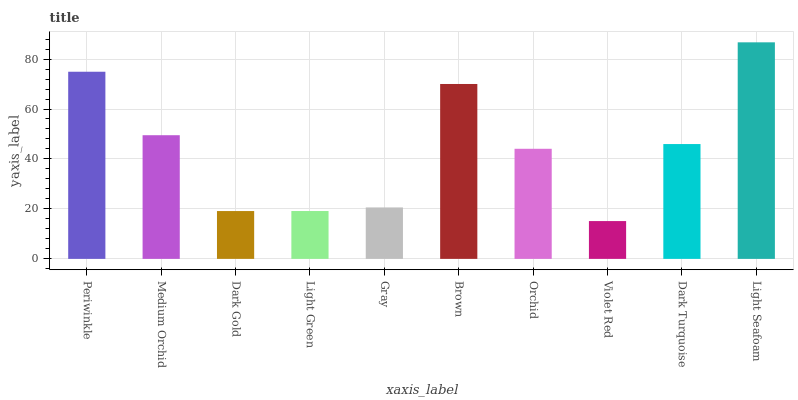Is Violet Red the minimum?
Answer yes or no. Yes. Is Light Seafoam the maximum?
Answer yes or no. Yes. Is Medium Orchid the minimum?
Answer yes or no. No. Is Medium Orchid the maximum?
Answer yes or no. No. Is Periwinkle greater than Medium Orchid?
Answer yes or no. Yes. Is Medium Orchid less than Periwinkle?
Answer yes or no. Yes. Is Medium Orchid greater than Periwinkle?
Answer yes or no. No. Is Periwinkle less than Medium Orchid?
Answer yes or no. No. Is Dark Turquoise the high median?
Answer yes or no. Yes. Is Orchid the low median?
Answer yes or no. Yes. Is Medium Orchid the high median?
Answer yes or no. No. Is Medium Orchid the low median?
Answer yes or no. No. 